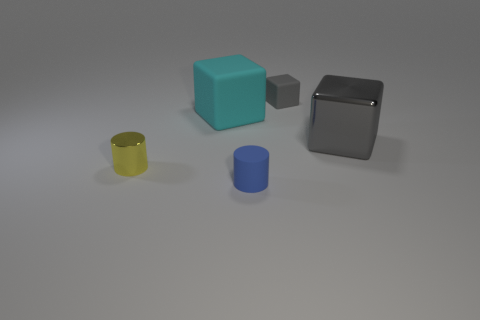Subtract all gray cubes. How many were subtracted if there are1gray cubes left? 1 Add 3 large things. How many objects exist? 8 Subtract all matte cubes. How many cubes are left? 1 Subtract all purple cylinders. How many gray cubes are left? 2 Subtract all purple cubes. Subtract all yellow cylinders. How many cubes are left? 3 Subtract 1 yellow cylinders. How many objects are left? 4 Subtract all cylinders. How many objects are left? 3 Subtract all tiny red cylinders. Subtract all tiny gray matte cubes. How many objects are left? 4 Add 4 large gray metallic blocks. How many large gray metallic blocks are left? 5 Add 4 small yellow things. How many small yellow things exist? 5 